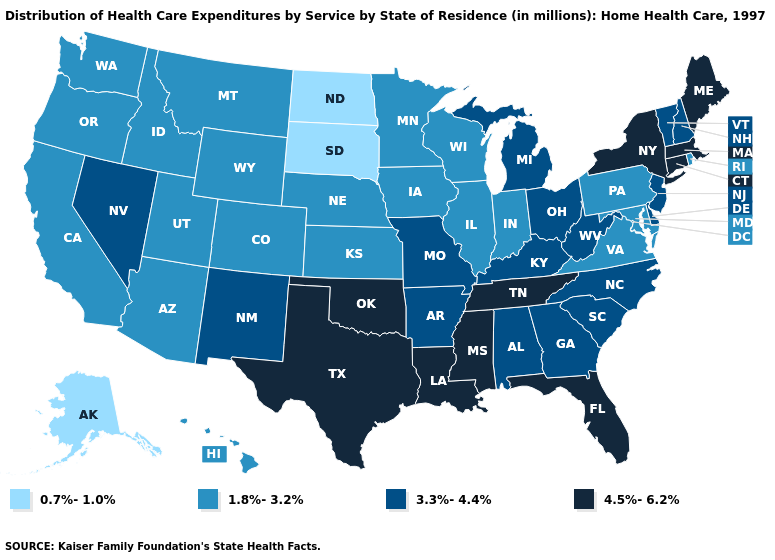Name the states that have a value in the range 1.8%-3.2%?
Concise answer only. Arizona, California, Colorado, Hawaii, Idaho, Illinois, Indiana, Iowa, Kansas, Maryland, Minnesota, Montana, Nebraska, Oregon, Pennsylvania, Rhode Island, Utah, Virginia, Washington, Wisconsin, Wyoming. What is the highest value in the USA?
Answer briefly. 4.5%-6.2%. What is the value of Tennessee?
Concise answer only. 4.5%-6.2%. Does Alaska have the lowest value in the USA?
Be succinct. Yes. What is the value of Georgia?
Give a very brief answer. 3.3%-4.4%. Does Rhode Island have the lowest value in the USA?
Keep it brief. No. What is the value of Tennessee?
Be succinct. 4.5%-6.2%. Does Alabama have the highest value in the USA?
Short answer required. No. What is the value of Indiana?
Answer briefly. 1.8%-3.2%. Name the states that have a value in the range 4.5%-6.2%?
Be succinct. Connecticut, Florida, Louisiana, Maine, Massachusetts, Mississippi, New York, Oklahoma, Tennessee, Texas. Does Oklahoma have the highest value in the USA?
Concise answer only. Yes. Is the legend a continuous bar?
Answer briefly. No. Name the states that have a value in the range 4.5%-6.2%?
Quick response, please. Connecticut, Florida, Louisiana, Maine, Massachusetts, Mississippi, New York, Oklahoma, Tennessee, Texas. Name the states that have a value in the range 1.8%-3.2%?
Short answer required. Arizona, California, Colorado, Hawaii, Idaho, Illinois, Indiana, Iowa, Kansas, Maryland, Minnesota, Montana, Nebraska, Oregon, Pennsylvania, Rhode Island, Utah, Virginia, Washington, Wisconsin, Wyoming. What is the lowest value in the USA?
Answer briefly. 0.7%-1.0%. 